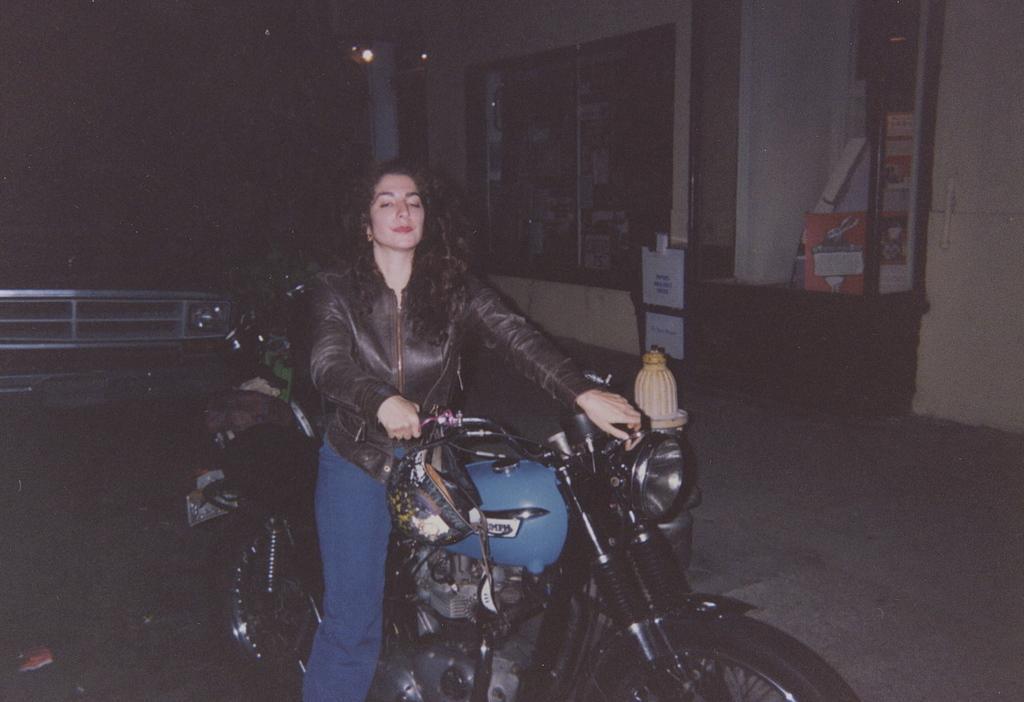In one or two sentences, can you explain what this image depicts? This is the picture taken in the nighttime. The woman is riding a bike. Background of the woman is a building. 